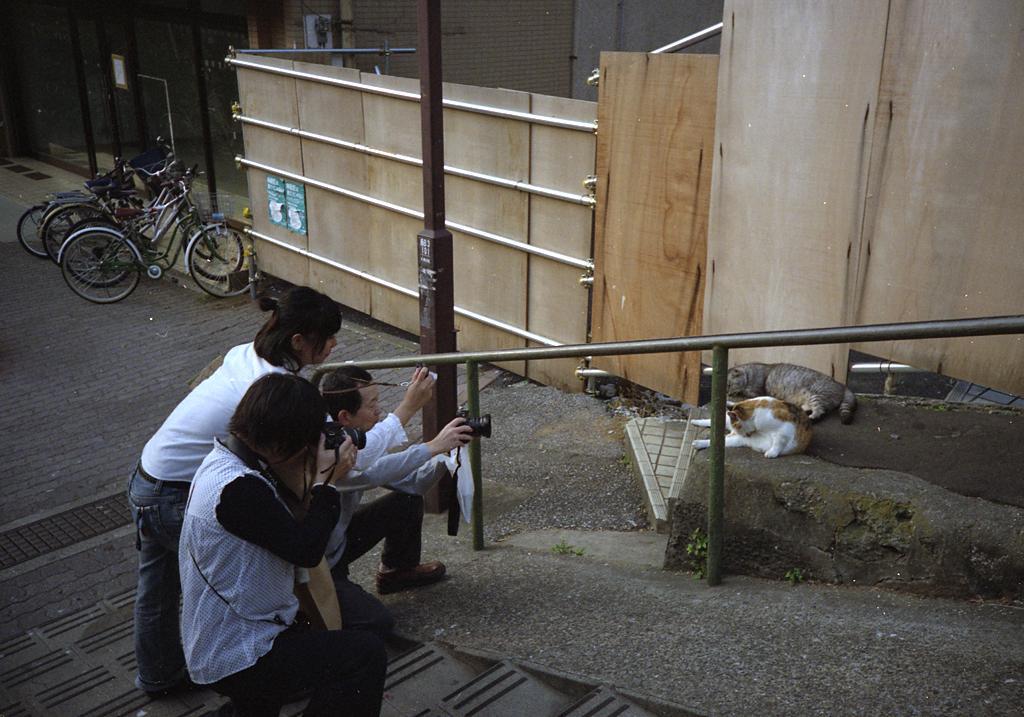Could you give a brief overview of what you see in this image? In the middle of the picture, we see three people are holding cameras in their hands and they are clicking photos of the cats. They are standing on the staircase. Beside them, we see a stair railing. Beside that, we see two cats sitting on the staircase. Beside that, we see a wooden wall. Behind that, we see a building in grey color. On the left side, there are bicycles which are parked on the road. 